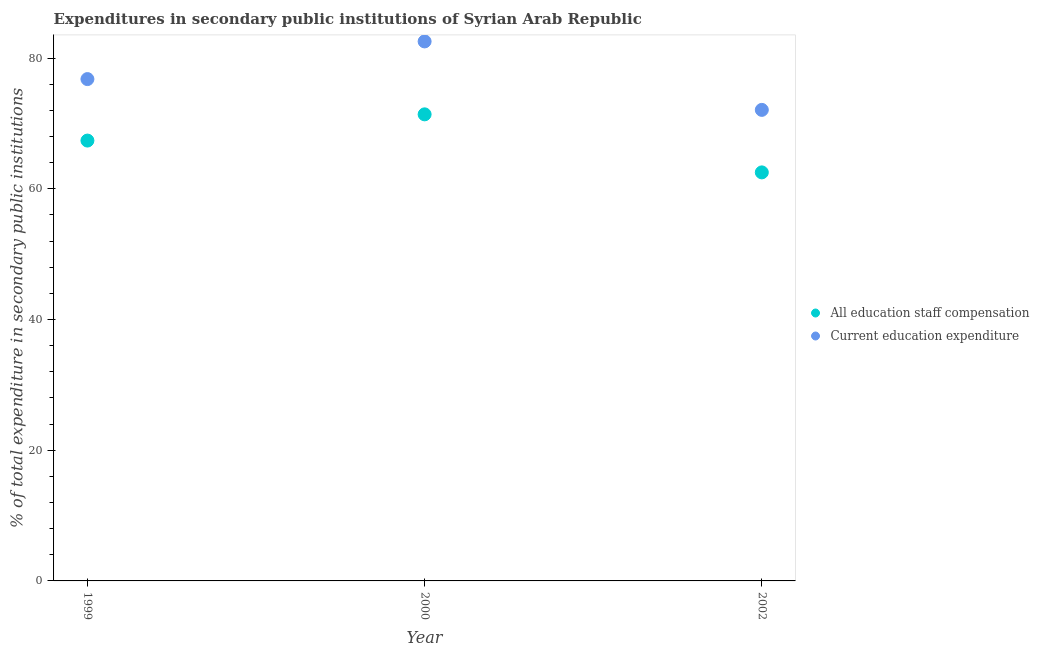Is the number of dotlines equal to the number of legend labels?
Make the answer very short. Yes. What is the expenditure in staff compensation in 1999?
Provide a short and direct response. 67.38. Across all years, what is the maximum expenditure in staff compensation?
Keep it short and to the point. 71.4. Across all years, what is the minimum expenditure in staff compensation?
Offer a terse response. 62.52. In which year was the expenditure in staff compensation maximum?
Make the answer very short. 2000. What is the total expenditure in education in the graph?
Your answer should be very brief. 231.43. What is the difference between the expenditure in education in 1999 and that in 2000?
Offer a terse response. -5.76. What is the difference between the expenditure in education in 1999 and the expenditure in staff compensation in 2000?
Provide a short and direct response. 5.4. What is the average expenditure in staff compensation per year?
Offer a terse response. 67.1. In the year 2000, what is the difference between the expenditure in staff compensation and expenditure in education?
Ensure brevity in your answer.  -11.16. What is the ratio of the expenditure in education in 1999 to that in 2002?
Your response must be concise. 1.07. Is the expenditure in education in 1999 less than that in 2000?
Provide a succinct answer. Yes. Is the difference between the expenditure in education in 1999 and 2000 greater than the difference between the expenditure in staff compensation in 1999 and 2000?
Provide a succinct answer. No. What is the difference between the highest and the second highest expenditure in staff compensation?
Provide a short and direct response. 4.01. What is the difference between the highest and the lowest expenditure in education?
Your response must be concise. 10.48. In how many years, is the expenditure in education greater than the average expenditure in education taken over all years?
Offer a very short reply. 1. Does the expenditure in education monotonically increase over the years?
Make the answer very short. No. Is the expenditure in education strictly greater than the expenditure in staff compensation over the years?
Keep it short and to the point. Yes. Is the expenditure in staff compensation strictly less than the expenditure in education over the years?
Your answer should be compact. Yes. Are the values on the major ticks of Y-axis written in scientific E-notation?
Your answer should be compact. No. How are the legend labels stacked?
Give a very brief answer. Vertical. What is the title of the graph?
Provide a succinct answer. Expenditures in secondary public institutions of Syrian Arab Republic. Does "Electricity and heat production" appear as one of the legend labels in the graph?
Make the answer very short. No. What is the label or title of the X-axis?
Make the answer very short. Year. What is the label or title of the Y-axis?
Your answer should be compact. % of total expenditure in secondary public institutions. What is the % of total expenditure in secondary public institutions of All education staff compensation in 1999?
Provide a succinct answer. 67.38. What is the % of total expenditure in secondary public institutions of Current education expenditure in 1999?
Ensure brevity in your answer.  76.79. What is the % of total expenditure in secondary public institutions in All education staff compensation in 2000?
Your answer should be very brief. 71.4. What is the % of total expenditure in secondary public institutions of Current education expenditure in 2000?
Provide a short and direct response. 82.56. What is the % of total expenditure in secondary public institutions of All education staff compensation in 2002?
Offer a terse response. 62.52. What is the % of total expenditure in secondary public institutions of Current education expenditure in 2002?
Keep it short and to the point. 72.08. Across all years, what is the maximum % of total expenditure in secondary public institutions in All education staff compensation?
Offer a terse response. 71.4. Across all years, what is the maximum % of total expenditure in secondary public institutions in Current education expenditure?
Make the answer very short. 82.56. Across all years, what is the minimum % of total expenditure in secondary public institutions in All education staff compensation?
Your answer should be very brief. 62.52. Across all years, what is the minimum % of total expenditure in secondary public institutions in Current education expenditure?
Make the answer very short. 72.08. What is the total % of total expenditure in secondary public institutions of All education staff compensation in the graph?
Ensure brevity in your answer.  201.3. What is the total % of total expenditure in secondary public institutions of Current education expenditure in the graph?
Your answer should be compact. 231.43. What is the difference between the % of total expenditure in secondary public institutions in All education staff compensation in 1999 and that in 2000?
Provide a succinct answer. -4.01. What is the difference between the % of total expenditure in secondary public institutions of Current education expenditure in 1999 and that in 2000?
Your answer should be very brief. -5.76. What is the difference between the % of total expenditure in secondary public institutions in All education staff compensation in 1999 and that in 2002?
Ensure brevity in your answer.  4.87. What is the difference between the % of total expenditure in secondary public institutions in Current education expenditure in 1999 and that in 2002?
Offer a very short reply. 4.71. What is the difference between the % of total expenditure in secondary public institutions in All education staff compensation in 2000 and that in 2002?
Make the answer very short. 8.88. What is the difference between the % of total expenditure in secondary public institutions of Current education expenditure in 2000 and that in 2002?
Your answer should be compact. 10.48. What is the difference between the % of total expenditure in secondary public institutions of All education staff compensation in 1999 and the % of total expenditure in secondary public institutions of Current education expenditure in 2000?
Your answer should be compact. -15.17. What is the difference between the % of total expenditure in secondary public institutions in All education staff compensation in 1999 and the % of total expenditure in secondary public institutions in Current education expenditure in 2002?
Keep it short and to the point. -4.7. What is the difference between the % of total expenditure in secondary public institutions of All education staff compensation in 2000 and the % of total expenditure in secondary public institutions of Current education expenditure in 2002?
Your answer should be very brief. -0.68. What is the average % of total expenditure in secondary public institutions of All education staff compensation per year?
Your response must be concise. 67.1. What is the average % of total expenditure in secondary public institutions of Current education expenditure per year?
Your answer should be very brief. 77.14. In the year 1999, what is the difference between the % of total expenditure in secondary public institutions of All education staff compensation and % of total expenditure in secondary public institutions of Current education expenditure?
Offer a very short reply. -9.41. In the year 2000, what is the difference between the % of total expenditure in secondary public institutions in All education staff compensation and % of total expenditure in secondary public institutions in Current education expenditure?
Ensure brevity in your answer.  -11.16. In the year 2002, what is the difference between the % of total expenditure in secondary public institutions in All education staff compensation and % of total expenditure in secondary public institutions in Current education expenditure?
Ensure brevity in your answer.  -9.57. What is the ratio of the % of total expenditure in secondary public institutions in All education staff compensation in 1999 to that in 2000?
Provide a succinct answer. 0.94. What is the ratio of the % of total expenditure in secondary public institutions in Current education expenditure in 1999 to that in 2000?
Make the answer very short. 0.93. What is the ratio of the % of total expenditure in secondary public institutions in All education staff compensation in 1999 to that in 2002?
Offer a terse response. 1.08. What is the ratio of the % of total expenditure in secondary public institutions of Current education expenditure in 1999 to that in 2002?
Make the answer very short. 1.07. What is the ratio of the % of total expenditure in secondary public institutions in All education staff compensation in 2000 to that in 2002?
Offer a terse response. 1.14. What is the ratio of the % of total expenditure in secondary public institutions in Current education expenditure in 2000 to that in 2002?
Keep it short and to the point. 1.15. What is the difference between the highest and the second highest % of total expenditure in secondary public institutions of All education staff compensation?
Your answer should be very brief. 4.01. What is the difference between the highest and the second highest % of total expenditure in secondary public institutions in Current education expenditure?
Provide a succinct answer. 5.76. What is the difference between the highest and the lowest % of total expenditure in secondary public institutions in All education staff compensation?
Your response must be concise. 8.88. What is the difference between the highest and the lowest % of total expenditure in secondary public institutions of Current education expenditure?
Offer a very short reply. 10.48. 